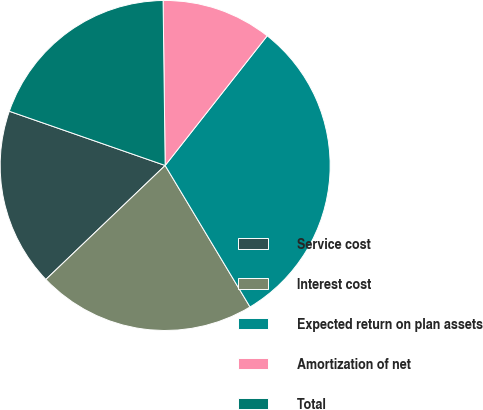Convert chart. <chart><loc_0><loc_0><loc_500><loc_500><pie_chart><fcel>Service cost<fcel>Interest cost<fcel>Expected return on plan assets<fcel>Amortization of net<fcel>Total<nl><fcel>17.47%<fcel>21.46%<fcel>30.79%<fcel>10.81%<fcel>19.47%<nl></chart> 